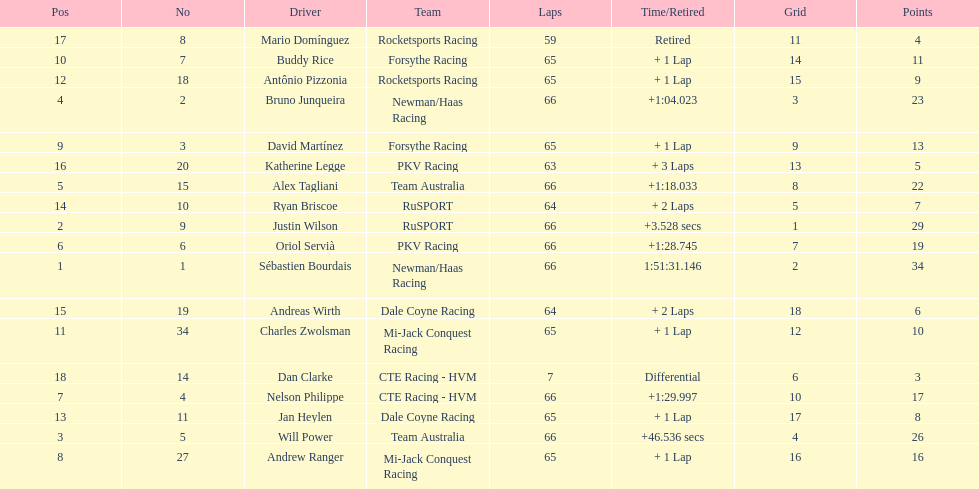Rice finished 10th. who finished next? Charles Zwolsman. 